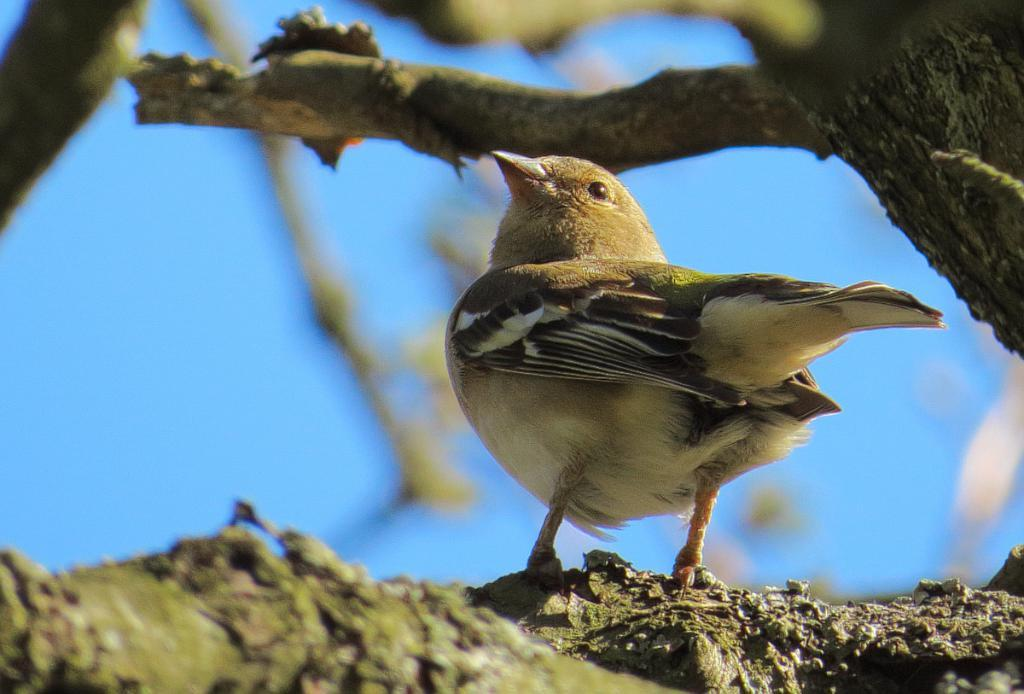What type of animal can be seen in the image? There is a bird in the image. Where is the bird located? The bird is on a tree. What part of the tree is visible in the image? The tree bark is visible in the image. What color is the sky in the image? The sky is blue in the image. How does the bird react to the surprise in the image? There is no surprise present in the image, so the bird's reaction cannot be determined. 